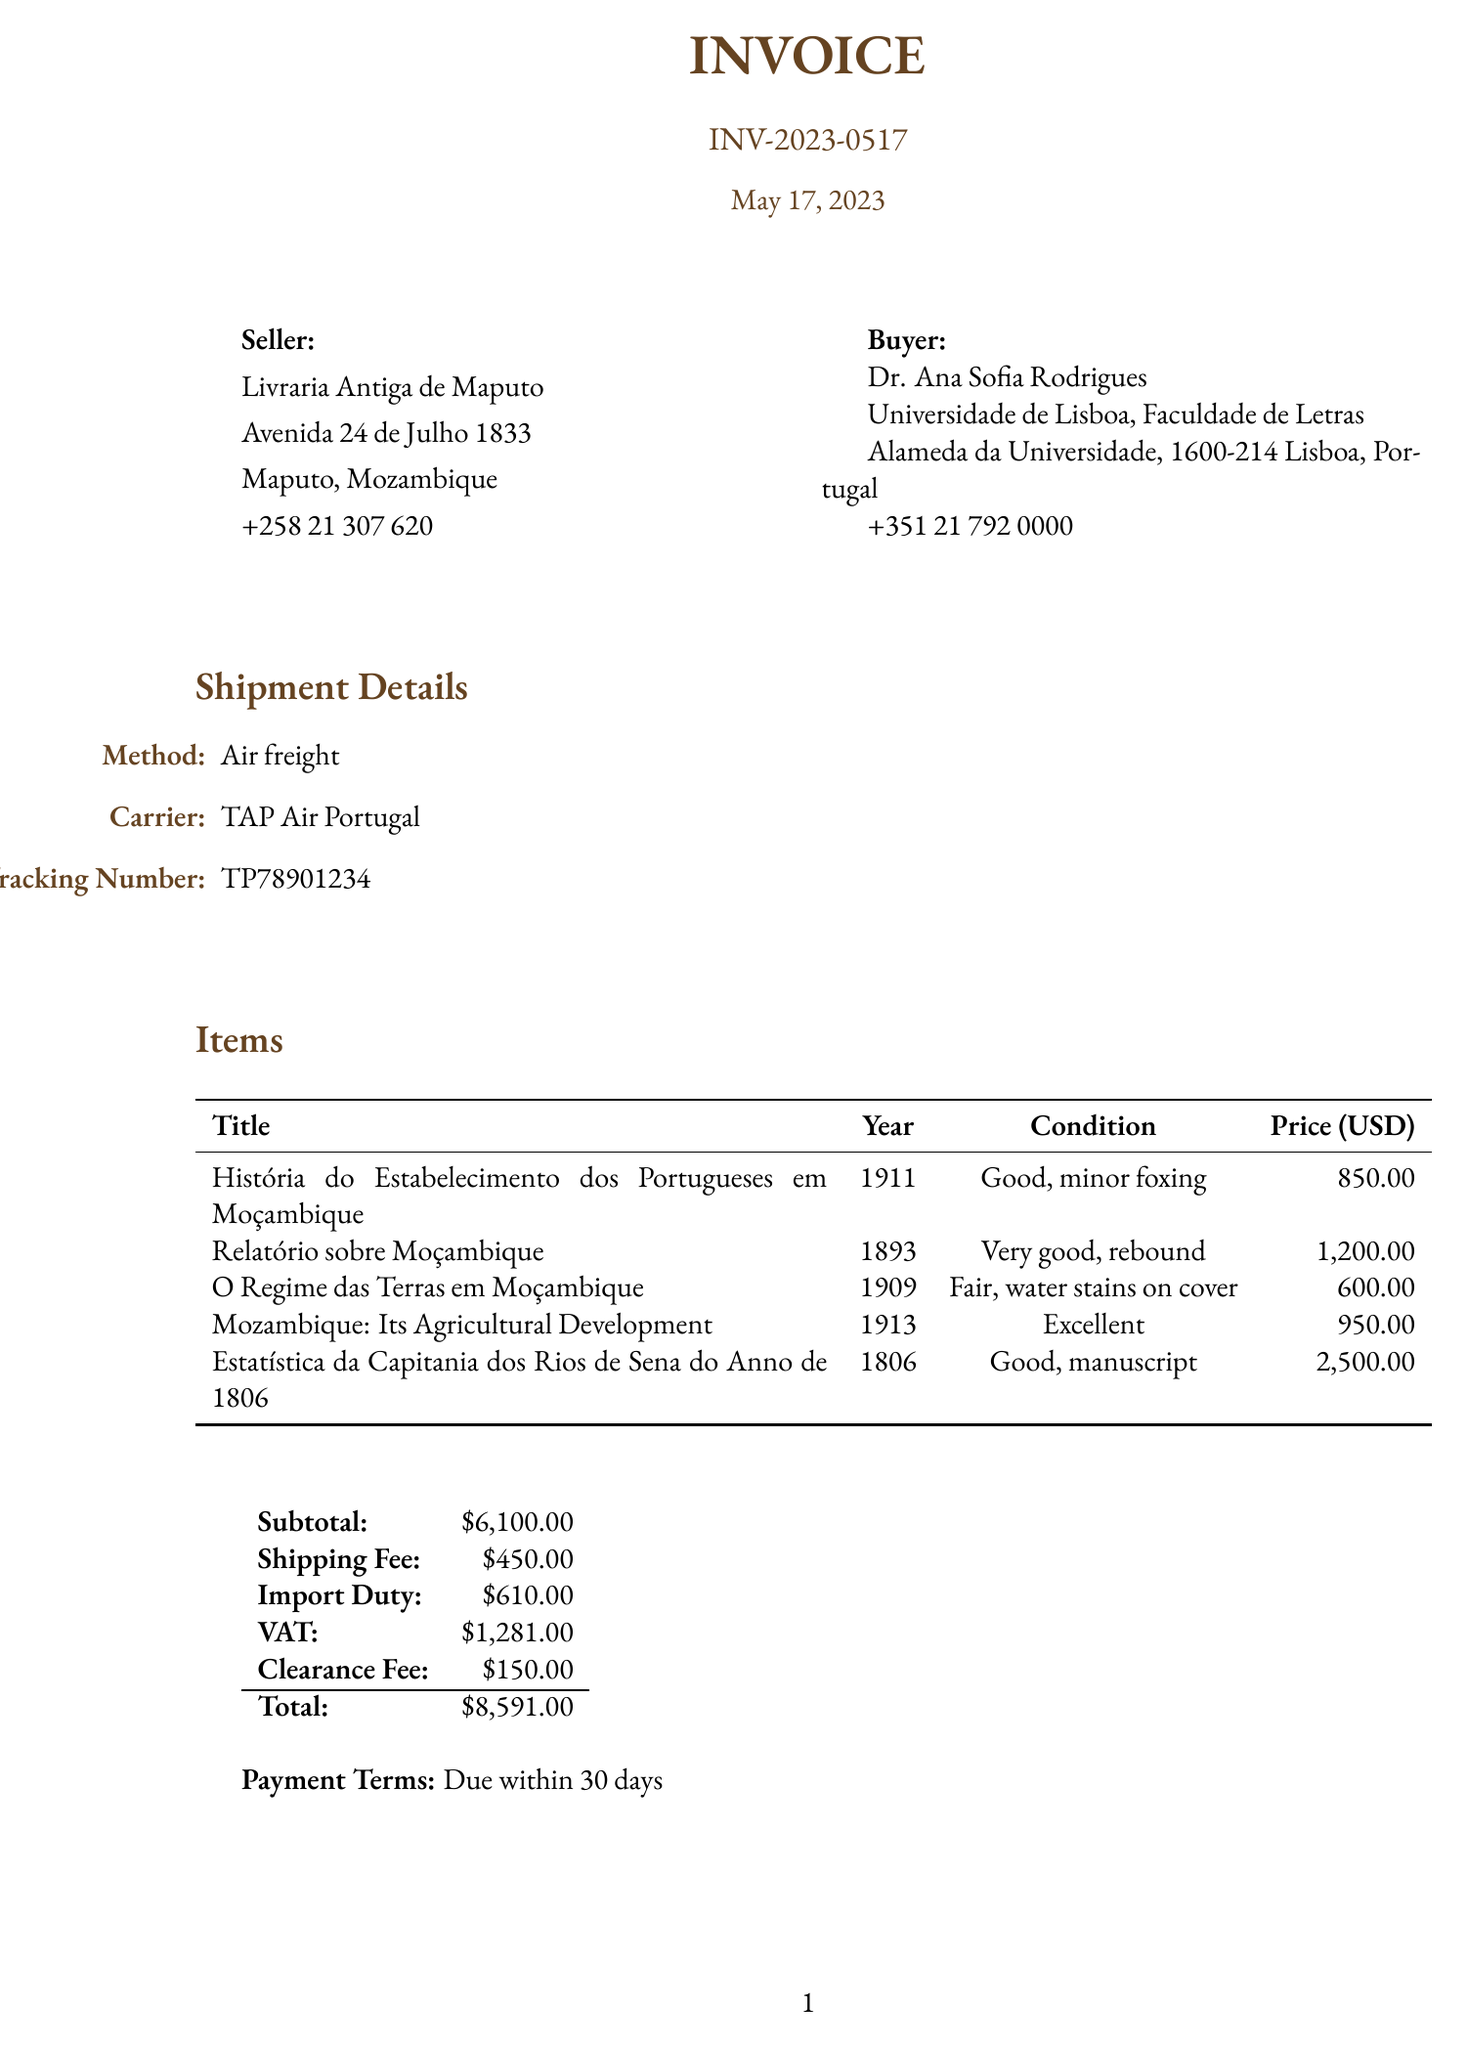What is the invoice number? The invoice number is specified at the top of the document under the title "INVOICE."
Answer: INV-2023-0517 Who is the seller? The seller is listed in the document along with their contact information.
Answer: Livraria Antiga de Maputo What is the total amount due? The total amount is calculated after adding all fees and is shown in the summary section.
Answer: $8,591.00 How much is the import duty? The import duty is a specific fee listed under customs fees in the document.
Answer: $610.00 What is the shipment method used? The method is labeled under shipment details in the document.
Answer: Air freight What is the condition of "Estatística da Capitania dos Rios de Sena do Anno de 1806"? The condition is stated in the items section for this specific book.
Answer: Good, manuscript How many books are listed in the invoice? The invoice lists the total number of items sold in the items section.
Answer: 5 What additional service is provided during transit? The additional service is mentioned in the additional notes section of the document.
Answer: Insurance coverage for full value during transit What is the payment terms stipulated in the invoice? Payment terms are specifically mentioned in the summary area of the document.
Answer: Due within 30 days 